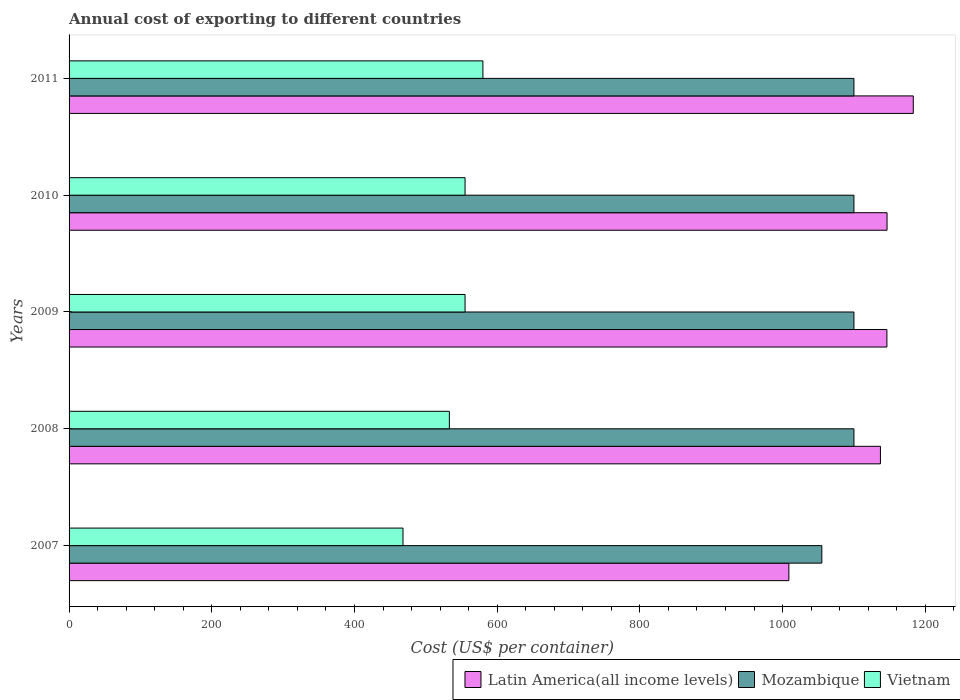Are the number of bars per tick equal to the number of legend labels?
Offer a very short reply. Yes. Are the number of bars on each tick of the Y-axis equal?
Offer a terse response. Yes. What is the total annual cost of exporting in Vietnam in 2008?
Make the answer very short. 533. Across all years, what is the maximum total annual cost of exporting in Vietnam?
Provide a short and direct response. 580. Across all years, what is the minimum total annual cost of exporting in Latin America(all income levels)?
Make the answer very short. 1008.81. In which year was the total annual cost of exporting in Mozambique maximum?
Your response must be concise. 2008. What is the total total annual cost of exporting in Latin America(all income levels) in the graph?
Provide a short and direct response. 5621.78. What is the difference between the total annual cost of exporting in Vietnam in 2007 and that in 2011?
Your response must be concise. -112. What is the difference between the total annual cost of exporting in Mozambique in 2011 and the total annual cost of exporting in Latin America(all income levels) in 2008?
Provide a succinct answer. -37.16. What is the average total annual cost of exporting in Vietnam per year?
Your response must be concise. 538.2. In the year 2008, what is the difference between the total annual cost of exporting in Mozambique and total annual cost of exporting in Latin America(all income levels)?
Give a very brief answer. -37.16. What is the ratio of the total annual cost of exporting in Vietnam in 2010 to that in 2011?
Give a very brief answer. 0.96. What is the difference between the highest and the second highest total annual cost of exporting in Mozambique?
Your answer should be very brief. 0. What is the difference between the highest and the lowest total annual cost of exporting in Vietnam?
Your answer should be very brief. 112. What does the 2nd bar from the top in 2010 represents?
Offer a very short reply. Mozambique. What does the 1st bar from the bottom in 2008 represents?
Your answer should be very brief. Latin America(all income levels). Is it the case that in every year, the sum of the total annual cost of exporting in Mozambique and total annual cost of exporting in Vietnam is greater than the total annual cost of exporting in Latin America(all income levels)?
Give a very brief answer. Yes. How many years are there in the graph?
Your answer should be very brief. 5. What is the difference between two consecutive major ticks on the X-axis?
Give a very brief answer. 200. Are the values on the major ticks of X-axis written in scientific E-notation?
Offer a very short reply. No. Does the graph contain any zero values?
Make the answer very short. No. How many legend labels are there?
Keep it short and to the point. 3. What is the title of the graph?
Keep it short and to the point. Annual cost of exporting to different countries. Does "Vanuatu" appear as one of the legend labels in the graph?
Your answer should be very brief. No. What is the label or title of the X-axis?
Your response must be concise. Cost (US$ per container). What is the Cost (US$ per container) in Latin America(all income levels) in 2007?
Keep it short and to the point. 1008.81. What is the Cost (US$ per container) of Mozambique in 2007?
Your response must be concise. 1055. What is the Cost (US$ per container) of Vietnam in 2007?
Make the answer very short. 468. What is the Cost (US$ per container) of Latin America(all income levels) in 2008?
Provide a succinct answer. 1137.16. What is the Cost (US$ per container) of Mozambique in 2008?
Give a very brief answer. 1100. What is the Cost (US$ per container) of Vietnam in 2008?
Your response must be concise. 533. What is the Cost (US$ per container) in Latin America(all income levels) in 2009?
Offer a very short reply. 1146.22. What is the Cost (US$ per container) in Mozambique in 2009?
Offer a very short reply. 1100. What is the Cost (US$ per container) in Vietnam in 2009?
Your response must be concise. 555. What is the Cost (US$ per container) of Latin America(all income levels) in 2010?
Give a very brief answer. 1146.41. What is the Cost (US$ per container) in Mozambique in 2010?
Provide a short and direct response. 1100. What is the Cost (US$ per container) of Vietnam in 2010?
Give a very brief answer. 555. What is the Cost (US$ per container) in Latin America(all income levels) in 2011?
Provide a succinct answer. 1183.18. What is the Cost (US$ per container) in Mozambique in 2011?
Provide a short and direct response. 1100. What is the Cost (US$ per container) of Vietnam in 2011?
Give a very brief answer. 580. Across all years, what is the maximum Cost (US$ per container) in Latin America(all income levels)?
Offer a very short reply. 1183.18. Across all years, what is the maximum Cost (US$ per container) in Mozambique?
Offer a very short reply. 1100. Across all years, what is the maximum Cost (US$ per container) in Vietnam?
Your answer should be compact. 580. Across all years, what is the minimum Cost (US$ per container) of Latin America(all income levels)?
Provide a succinct answer. 1008.81. Across all years, what is the minimum Cost (US$ per container) in Mozambique?
Ensure brevity in your answer.  1055. Across all years, what is the minimum Cost (US$ per container) in Vietnam?
Provide a short and direct response. 468. What is the total Cost (US$ per container) of Latin America(all income levels) in the graph?
Your response must be concise. 5621.78. What is the total Cost (US$ per container) in Mozambique in the graph?
Your answer should be very brief. 5455. What is the total Cost (US$ per container) of Vietnam in the graph?
Ensure brevity in your answer.  2691. What is the difference between the Cost (US$ per container) in Latin America(all income levels) in 2007 and that in 2008?
Offer a very short reply. -128.34. What is the difference between the Cost (US$ per container) in Mozambique in 2007 and that in 2008?
Ensure brevity in your answer.  -45. What is the difference between the Cost (US$ per container) of Vietnam in 2007 and that in 2008?
Your answer should be compact. -65. What is the difference between the Cost (US$ per container) of Latin America(all income levels) in 2007 and that in 2009?
Give a very brief answer. -137.41. What is the difference between the Cost (US$ per container) of Mozambique in 2007 and that in 2009?
Your response must be concise. -45. What is the difference between the Cost (US$ per container) of Vietnam in 2007 and that in 2009?
Your answer should be very brief. -87. What is the difference between the Cost (US$ per container) of Latin America(all income levels) in 2007 and that in 2010?
Your answer should be compact. -137.59. What is the difference between the Cost (US$ per container) in Mozambique in 2007 and that in 2010?
Make the answer very short. -45. What is the difference between the Cost (US$ per container) in Vietnam in 2007 and that in 2010?
Give a very brief answer. -87. What is the difference between the Cost (US$ per container) of Latin America(all income levels) in 2007 and that in 2011?
Keep it short and to the point. -174.37. What is the difference between the Cost (US$ per container) in Mozambique in 2007 and that in 2011?
Your answer should be very brief. -45. What is the difference between the Cost (US$ per container) of Vietnam in 2007 and that in 2011?
Offer a very short reply. -112. What is the difference between the Cost (US$ per container) of Latin America(all income levels) in 2008 and that in 2009?
Your answer should be compact. -9.06. What is the difference between the Cost (US$ per container) in Latin America(all income levels) in 2008 and that in 2010?
Give a very brief answer. -9.25. What is the difference between the Cost (US$ per container) of Mozambique in 2008 and that in 2010?
Your answer should be very brief. 0. What is the difference between the Cost (US$ per container) in Latin America(all income levels) in 2008 and that in 2011?
Offer a terse response. -46.03. What is the difference between the Cost (US$ per container) in Mozambique in 2008 and that in 2011?
Make the answer very short. 0. What is the difference between the Cost (US$ per container) in Vietnam in 2008 and that in 2011?
Provide a short and direct response. -47. What is the difference between the Cost (US$ per container) in Latin America(all income levels) in 2009 and that in 2010?
Your answer should be compact. -0.19. What is the difference between the Cost (US$ per container) in Latin America(all income levels) in 2009 and that in 2011?
Offer a very short reply. -36.96. What is the difference between the Cost (US$ per container) of Vietnam in 2009 and that in 2011?
Offer a very short reply. -25. What is the difference between the Cost (US$ per container) in Latin America(all income levels) in 2010 and that in 2011?
Provide a succinct answer. -36.78. What is the difference between the Cost (US$ per container) of Latin America(all income levels) in 2007 and the Cost (US$ per container) of Mozambique in 2008?
Offer a terse response. -91.19. What is the difference between the Cost (US$ per container) of Latin America(all income levels) in 2007 and the Cost (US$ per container) of Vietnam in 2008?
Make the answer very short. 475.81. What is the difference between the Cost (US$ per container) of Mozambique in 2007 and the Cost (US$ per container) of Vietnam in 2008?
Make the answer very short. 522. What is the difference between the Cost (US$ per container) in Latin America(all income levels) in 2007 and the Cost (US$ per container) in Mozambique in 2009?
Ensure brevity in your answer.  -91.19. What is the difference between the Cost (US$ per container) of Latin America(all income levels) in 2007 and the Cost (US$ per container) of Vietnam in 2009?
Make the answer very short. 453.81. What is the difference between the Cost (US$ per container) in Mozambique in 2007 and the Cost (US$ per container) in Vietnam in 2009?
Your answer should be compact. 500. What is the difference between the Cost (US$ per container) in Latin America(all income levels) in 2007 and the Cost (US$ per container) in Mozambique in 2010?
Your answer should be very brief. -91.19. What is the difference between the Cost (US$ per container) in Latin America(all income levels) in 2007 and the Cost (US$ per container) in Vietnam in 2010?
Your answer should be very brief. 453.81. What is the difference between the Cost (US$ per container) in Latin America(all income levels) in 2007 and the Cost (US$ per container) in Mozambique in 2011?
Keep it short and to the point. -91.19. What is the difference between the Cost (US$ per container) in Latin America(all income levels) in 2007 and the Cost (US$ per container) in Vietnam in 2011?
Provide a succinct answer. 428.81. What is the difference between the Cost (US$ per container) in Mozambique in 2007 and the Cost (US$ per container) in Vietnam in 2011?
Ensure brevity in your answer.  475. What is the difference between the Cost (US$ per container) in Latin America(all income levels) in 2008 and the Cost (US$ per container) in Mozambique in 2009?
Ensure brevity in your answer.  37.16. What is the difference between the Cost (US$ per container) in Latin America(all income levels) in 2008 and the Cost (US$ per container) in Vietnam in 2009?
Make the answer very short. 582.16. What is the difference between the Cost (US$ per container) in Mozambique in 2008 and the Cost (US$ per container) in Vietnam in 2009?
Ensure brevity in your answer.  545. What is the difference between the Cost (US$ per container) in Latin America(all income levels) in 2008 and the Cost (US$ per container) in Mozambique in 2010?
Your answer should be very brief. 37.16. What is the difference between the Cost (US$ per container) in Latin America(all income levels) in 2008 and the Cost (US$ per container) in Vietnam in 2010?
Your answer should be very brief. 582.16. What is the difference between the Cost (US$ per container) in Mozambique in 2008 and the Cost (US$ per container) in Vietnam in 2010?
Your answer should be very brief. 545. What is the difference between the Cost (US$ per container) of Latin America(all income levels) in 2008 and the Cost (US$ per container) of Mozambique in 2011?
Your answer should be very brief. 37.16. What is the difference between the Cost (US$ per container) in Latin America(all income levels) in 2008 and the Cost (US$ per container) in Vietnam in 2011?
Your answer should be compact. 557.16. What is the difference between the Cost (US$ per container) of Mozambique in 2008 and the Cost (US$ per container) of Vietnam in 2011?
Make the answer very short. 520. What is the difference between the Cost (US$ per container) in Latin America(all income levels) in 2009 and the Cost (US$ per container) in Mozambique in 2010?
Give a very brief answer. 46.22. What is the difference between the Cost (US$ per container) of Latin America(all income levels) in 2009 and the Cost (US$ per container) of Vietnam in 2010?
Offer a very short reply. 591.22. What is the difference between the Cost (US$ per container) in Mozambique in 2009 and the Cost (US$ per container) in Vietnam in 2010?
Make the answer very short. 545. What is the difference between the Cost (US$ per container) in Latin America(all income levels) in 2009 and the Cost (US$ per container) in Mozambique in 2011?
Your answer should be very brief. 46.22. What is the difference between the Cost (US$ per container) of Latin America(all income levels) in 2009 and the Cost (US$ per container) of Vietnam in 2011?
Give a very brief answer. 566.22. What is the difference between the Cost (US$ per container) of Mozambique in 2009 and the Cost (US$ per container) of Vietnam in 2011?
Your answer should be compact. 520. What is the difference between the Cost (US$ per container) in Latin America(all income levels) in 2010 and the Cost (US$ per container) in Mozambique in 2011?
Offer a very short reply. 46.41. What is the difference between the Cost (US$ per container) of Latin America(all income levels) in 2010 and the Cost (US$ per container) of Vietnam in 2011?
Ensure brevity in your answer.  566.41. What is the difference between the Cost (US$ per container) in Mozambique in 2010 and the Cost (US$ per container) in Vietnam in 2011?
Give a very brief answer. 520. What is the average Cost (US$ per container) of Latin America(all income levels) per year?
Provide a short and direct response. 1124.36. What is the average Cost (US$ per container) in Mozambique per year?
Keep it short and to the point. 1091. What is the average Cost (US$ per container) of Vietnam per year?
Your response must be concise. 538.2. In the year 2007, what is the difference between the Cost (US$ per container) of Latin America(all income levels) and Cost (US$ per container) of Mozambique?
Provide a short and direct response. -46.19. In the year 2007, what is the difference between the Cost (US$ per container) in Latin America(all income levels) and Cost (US$ per container) in Vietnam?
Offer a very short reply. 540.81. In the year 2007, what is the difference between the Cost (US$ per container) in Mozambique and Cost (US$ per container) in Vietnam?
Offer a very short reply. 587. In the year 2008, what is the difference between the Cost (US$ per container) in Latin America(all income levels) and Cost (US$ per container) in Mozambique?
Offer a terse response. 37.16. In the year 2008, what is the difference between the Cost (US$ per container) of Latin America(all income levels) and Cost (US$ per container) of Vietnam?
Provide a short and direct response. 604.16. In the year 2008, what is the difference between the Cost (US$ per container) of Mozambique and Cost (US$ per container) of Vietnam?
Provide a short and direct response. 567. In the year 2009, what is the difference between the Cost (US$ per container) in Latin America(all income levels) and Cost (US$ per container) in Mozambique?
Your answer should be compact. 46.22. In the year 2009, what is the difference between the Cost (US$ per container) in Latin America(all income levels) and Cost (US$ per container) in Vietnam?
Offer a terse response. 591.22. In the year 2009, what is the difference between the Cost (US$ per container) in Mozambique and Cost (US$ per container) in Vietnam?
Provide a short and direct response. 545. In the year 2010, what is the difference between the Cost (US$ per container) of Latin America(all income levels) and Cost (US$ per container) of Mozambique?
Your response must be concise. 46.41. In the year 2010, what is the difference between the Cost (US$ per container) of Latin America(all income levels) and Cost (US$ per container) of Vietnam?
Make the answer very short. 591.41. In the year 2010, what is the difference between the Cost (US$ per container) in Mozambique and Cost (US$ per container) in Vietnam?
Ensure brevity in your answer.  545. In the year 2011, what is the difference between the Cost (US$ per container) in Latin America(all income levels) and Cost (US$ per container) in Mozambique?
Provide a succinct answer. 83.18. In the year 2011, what is the difference between the Cost (US$ per container) of Latin America(all income levels) and Cost (US$ per container) of Vietnam?
Your answer should be compact. 603.18. In the year 2011, what is the difference between the Cost (US$ per container) in Mozambique and Cost (US$ per container) in Vietnam?
Make the answer very short. 520. What is the ratio of the Cost (US$ per container) of Latin America(all income levels) in 2007 to that in 2008?
Provide a succinct answer. 0.89. What is the ratio of the Cost (US$ per container) in Mozambique in 2007 to that in 2008?
Offer a very short reply. 0.96. What is the ratio of the Cost (US$ per container) of Vietnam in 2007 to that in 2008?
Make the answer very short. 0.88. What is the ratio of the Cost (US$ per container) of Latin America(all income levels) in 2007 to that in 2009?
Your answer should be very brief. 0.88. What is the ratio of the Cost (US$ per container) of Mozambique in 2007 to that in 2009?
Your answer should be compact. 0.96. What is the ratio of the Cost (US$ per container) in Vietnam in 2007 to that in 2009?
Ensure brevity in your answer.  0.84. What is the ratio of the Cost (US$ per container) in Latin America(all income levels) in 2007 to that in 2010?
Your answer should be very brief. 0.88. What is the ratio of the Cost (US$ per container) of Mozambique in 2007 to that in 2010?
Make the answer very short. 0.96. What is the ratio of the Cost (US$ per container) in Vietnam in 2007 to that in 2010?
Keep it short and to the point. 0.84. What is the ratio of the Cost (US$ per container) in Latin America(all income levels) in 2007 to that in 2011?
Your response must be concise. 0.85. What is the ratio of the Cost (US$ per container) of Mozambique in 2007 to that in 2011?
Make the answer very short. 0.96. What is the ratio of the Cost (US$ per container) in Vietnam in 2007 to that in 2011?
Your answer should be very brief. 0.81. What is the ratio of the Cost (US$ per container) in Latin America(all income levels) in 2008 to that in 2009?
Provide a short and direct response. 0.99. What is the ratio of the Cost (US$ per container) of Vietnam in 2008 to that in 2009?
Offer a very short reply. 0.96. What is the ratio of the Cost (US$ per container) of Latin America(all income levels) in 2008 to that in 2010?
Keep it short and to the point. 0.99. What is the ratio of the Cost (US$ per container) of Vietnam in 2008 to that in 2010?
Your answer should be compact. 0.96. What is the ratio of the Cost (US$ per container) in Latin America(all income levels) in 2008 to that in 2011?
Offer a very short reply. 0.96. What is the ratio of the Cost (US$ per container) in Mozambique in 2008 to that in 2011?
Provide a short and direct response. 1. What is the ratio of the Cost (US$ per container) of Vietnam in 2008 to that in 2011?
Provide a succinct answer. 0.92. What is the ratio of the Cost (US$ per container) in Mozambique in 2009 to that in 2010?
Your response must be concise. 1. What is the ratio of the Cost (US$ per container) in Latin America(all income levels) in 2009 to that in 2011?
Your answer should be very brief. 0.97. What is the ratio of the Cost (US$ per container) in Mozambique in 2009 to that in 2011?
Keep it short and to the point. 1. What is the ratio of the Cost (US$ per container) in Vietnam in 2009 to that in 2011?
Make the answer very short. 0.96. What is the ratio of the Cost (US$ per container) of Latin America(all income levels) in 2010 to that in 2011?
Offer a terse response. 0.97. What is the ratio of the Cost (US$ per container) of Mozambique in 2010 to that in 2011?
Give a very brief answer. 1. What is the ratio of the Cost (US$ per container) of Vietnam in 2010 to that in 2011?
Provide a short and direct response. 0.96. What is the difference between the highest and the second highest Cost (US$ per container) in Latin America(all income levels)?
Ensure brevity in your answer.  36.78. What is the difference between the highest and the lowest Cost (US$ per container) in Latin America(all income levels)?
Provide a short and direct response. 174.37. What is the difference between the highest and the lowest Cost (US$ per container) in Mozambique?
Offer a terse response. 45. What is the difference between the highest and the lowest Cost (US$ per container) in Vietnam?
Offer a very short reply. 112. 